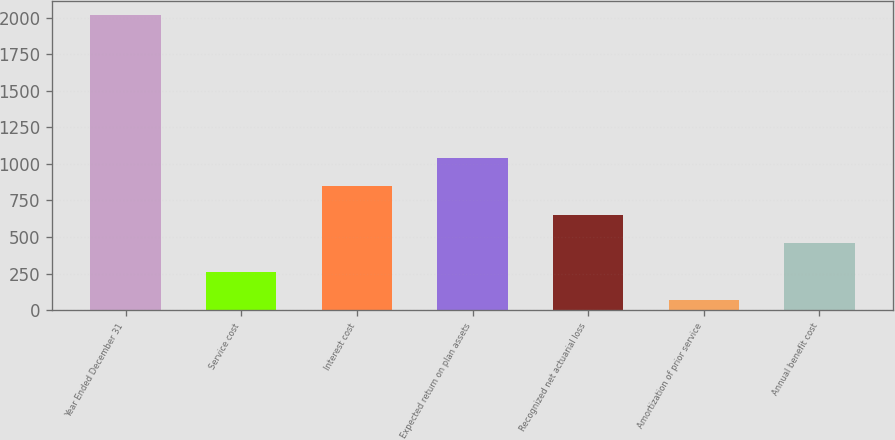<chart> <loc_0><loc_0><loc_500><loc_500><bar_chart><fcel>Year Ended December 31<fcel>Service cost<fcel>Interest cost<fcel>Expected return on plan assets<fcel>Recognized net actuarial loss<fcel>Amortization of prior service<fcel>Annual benefit cost<nl><fcel>2015<fcel>261.8<fcel>846.2<fcel>1041<fcel>651.4<fcel>67<fcel>456.6<nl></chart> 